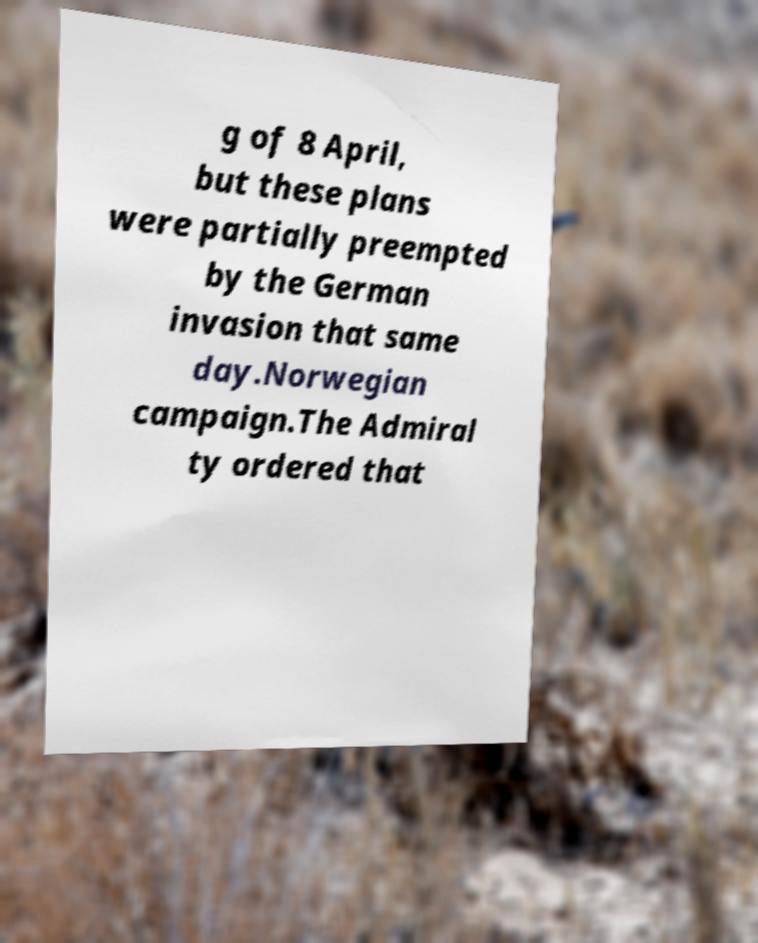Can you accurately transcribe the text from the provided image for me? g of 8 April, but these plans were partially preempted by the German invasion that same day.Norwegian campaign.The Admiral ty ordered that 